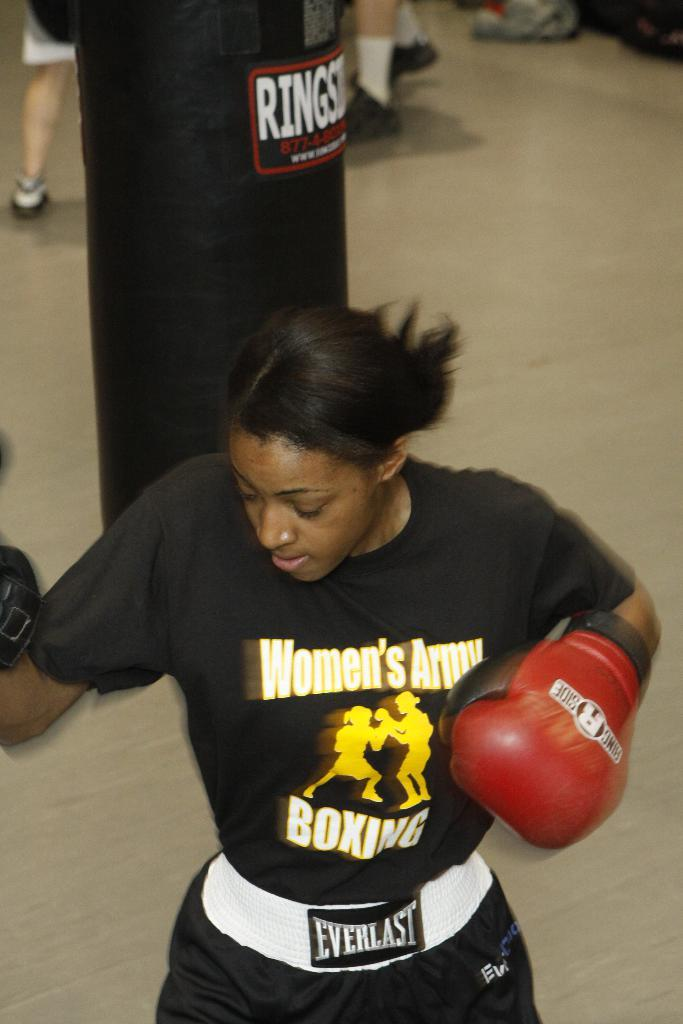<image>
Present a compact description of the photo's key features. a girl with a shirt that has the word boxing on it 